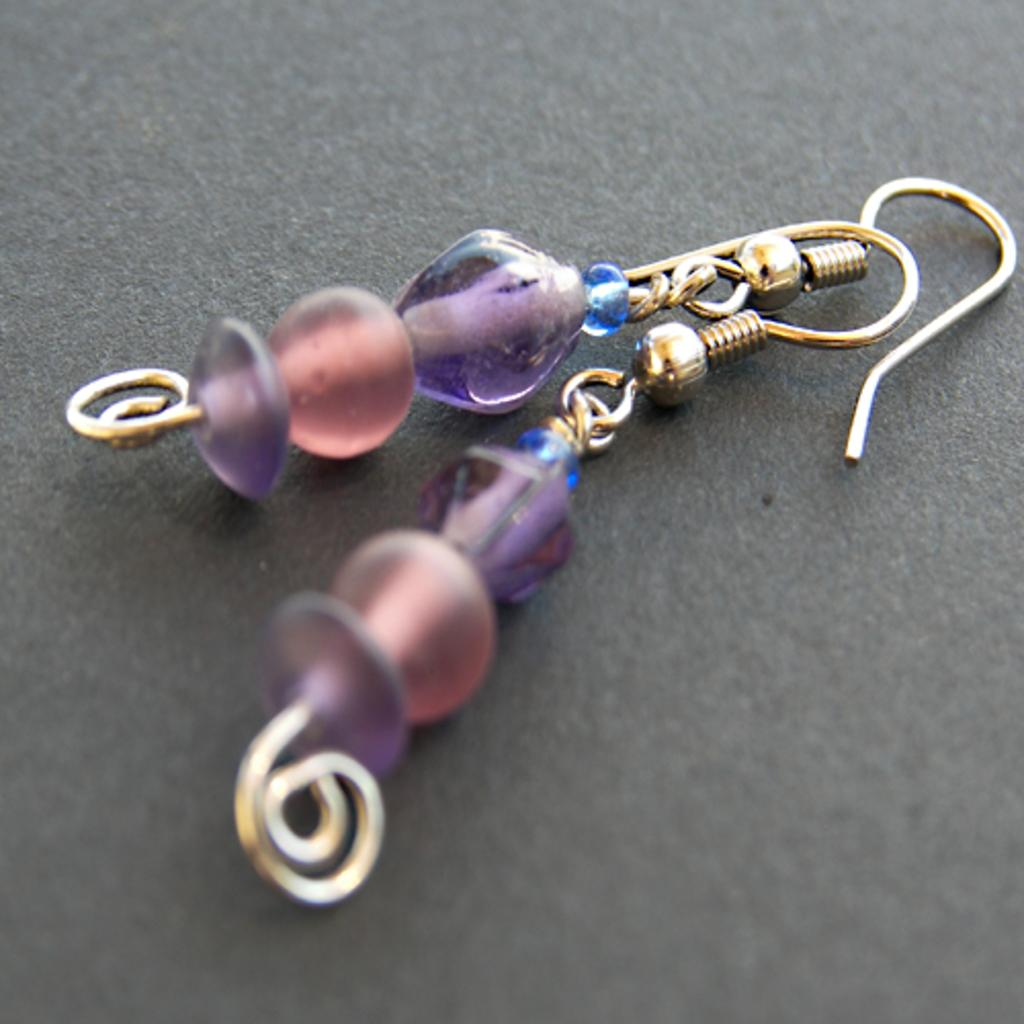What type of accessory is featured in the image? There are two long bead earrings in the image. What color is the background of the image? The background of the image is black. What type of lunchroom furniture can be seen in the image? There is no lunchroom furniture present in the image; it features two long bead earrings against a black background. How many bells are hanging from the trees in the image? There are no trees or bells present in the image; it only contains two long bead earrings against a black background. 